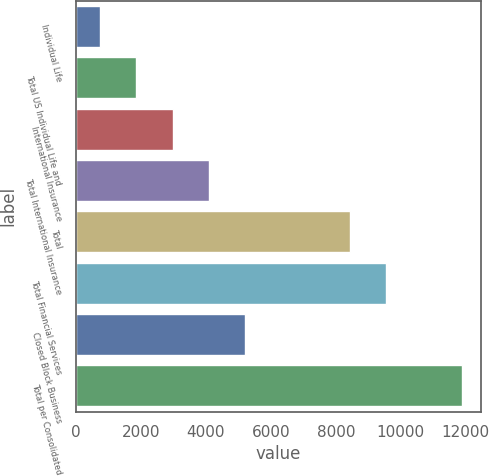Convert chart to OTSL. <chart><loc_0><loc_0><loc_500><loc_500><bar_chart><fcel>Individual Life<fcel>Total US Individual Life and<fcel>International Insurance<fcel>Total International Insurance<fcel>Total<fcel>Total Financial Services<fcel>Closed Block Business<fcel>Total per Consolidated<nl><fcel>749<fcel>1862.2<fcel>2975.4<fcel>4088.6<fcel>8430<fcel>9543.2<fcel>5201.8<fcel>11881<nl></chart> 